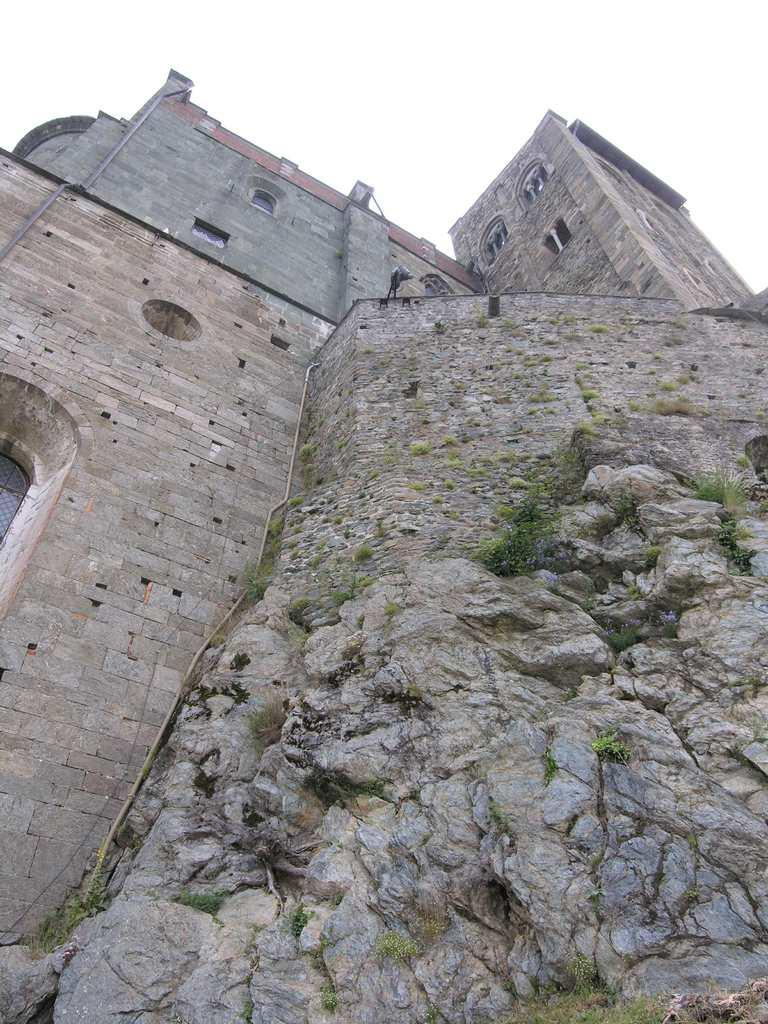What type of building is visible in the image? There is a building with a brick wall and windows in the image. What is present on the wall in the image? There are plants on the wall in the image. What can be seen in the background of the image? There are trees in the background of the image. What type of watch is the tree wearing in the image? There are no watches or trees wearing watches in the image. Can you tell me how much toothpaste is on the plants in the image? There is no toothpaste present in the image; it features a building, a wall with plants, and trees in the background. 